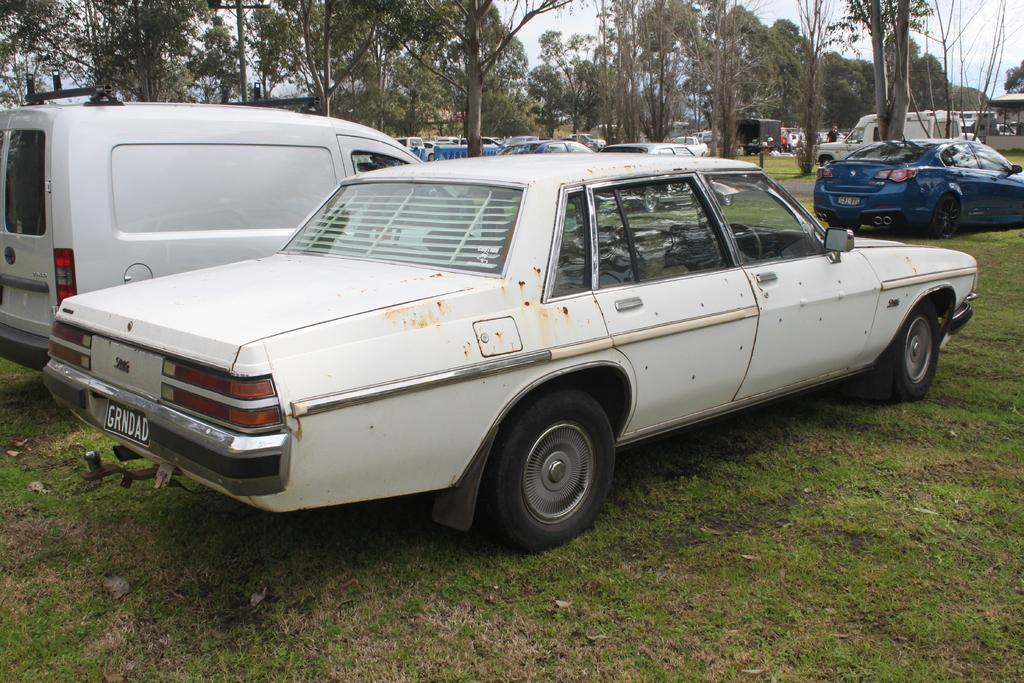What can be seen on the ground in the image? There are many cars parked on the ground in the image. What type of vegetation is present at the bottom of the image? There is green grass at the bottom of the image. What can be seen in the background of the image? There are trees in the background of the image. What is visible at the top of the image? The sky is visible at the top of the image. Where is the division located in the image? There is no division present in the image. What type of brush can be seen in the image? There is no brush present in the image. 